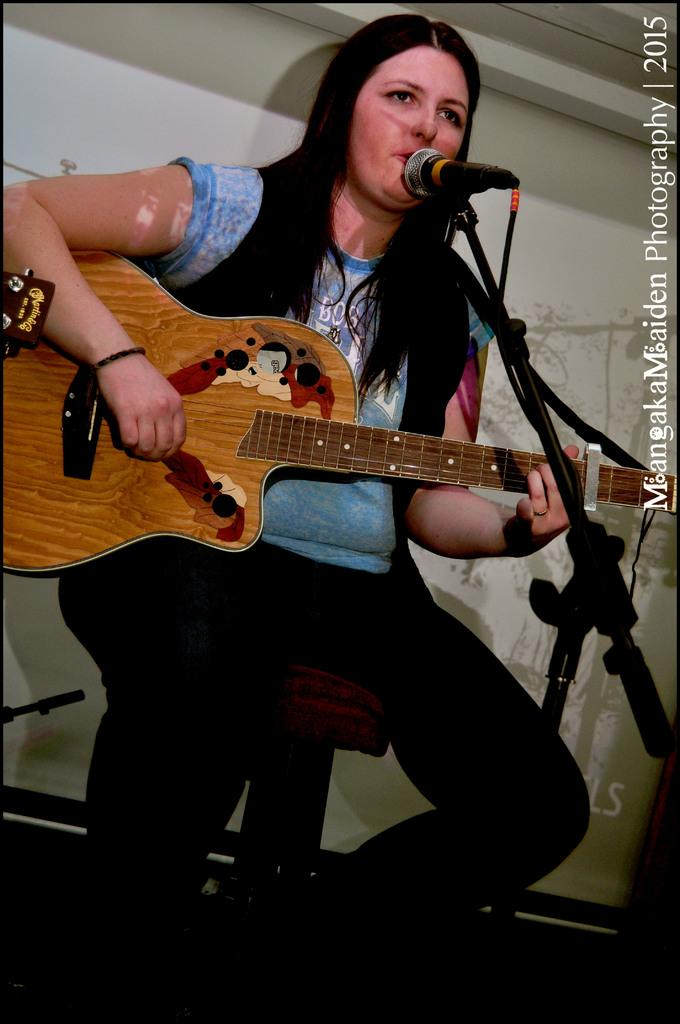Who is the main subject in the image? There is a woman in the image. What is the woman doing in the image? The woman is sitting, playing a guitar, and singing. What objects are present in the image related to the woman's performance? There is a screen at the back of the image and a microphone at the front of the image. What type of ball can be seen rolling across the stage in the image? There is no ball present in the image; the woman is playing a guitar and singing. 